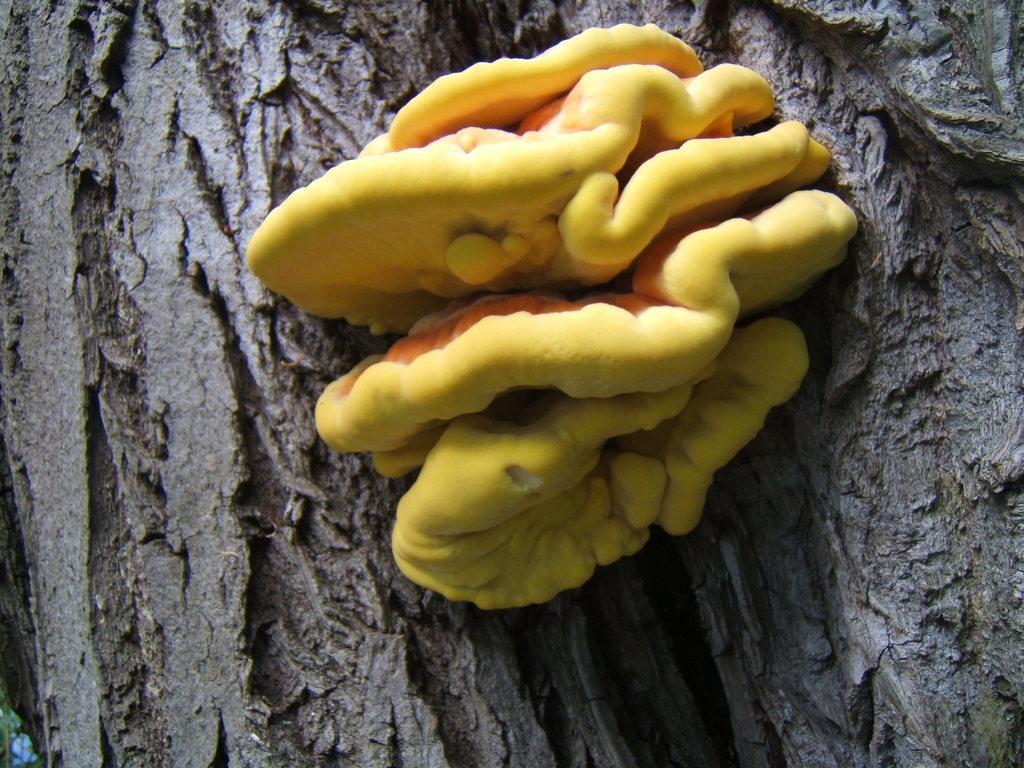Please provide a concise description of this image. In the picture we can see a branch of the tree on it, we can see some mushroom which is in the kind of a flower and yellow in color. 